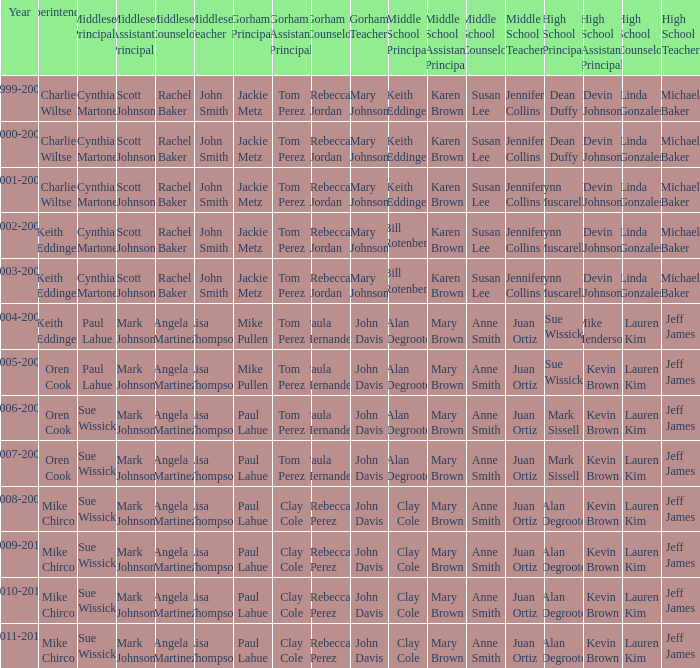Who were the superintendent(s) when the middle school principal was alan degroote, the gorham principal was paul lahue, and the year was 2006-2007? Oren Cook. 